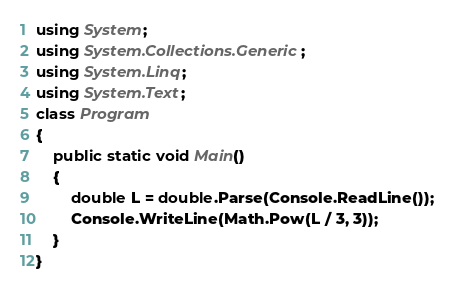<code> <loc_0><loc_0><loc_500><loc_500><_C#_>using System;
using System.Collections.Generic;
using System.Linq;
using System.Text;
class Program
{
    public static void Main()
    {
        double L = double.Parse(Console.ReadLine());
        Console.WriteLine(Math.Pow(L / 3, 3));
    }
}</code> 